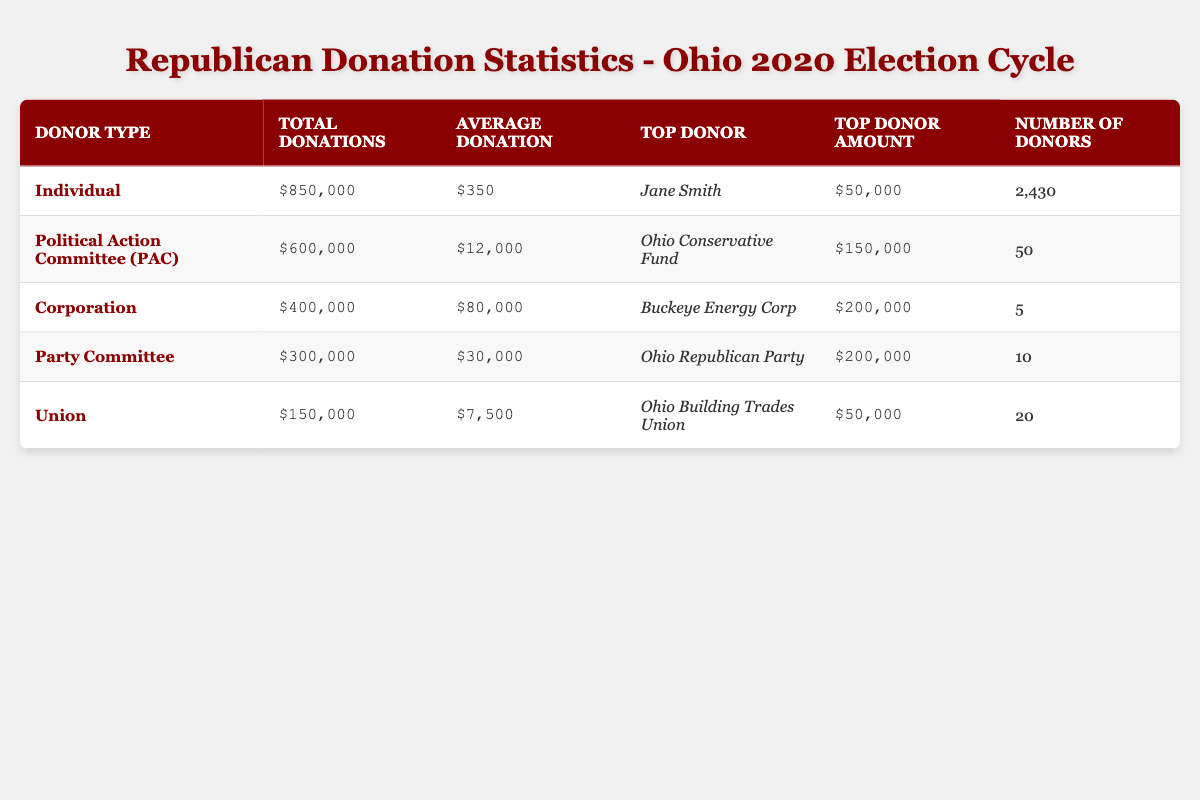What is the total amount donated by individual donors? The total donations from individuals are explicitly stated in the table as $850,000.
Answer: $850,000 Who is the top donor from corporations and how much did they donate? The table lists Buckeye Energy Corp as the top donor for corporations with a donation amount of $200,000.
Answer: Buckeye Energy Corp, $200,000 How many individual donors contributed during the 2020 election cycle? The table provides the number of individual donors as 2,430.
Answer: 2,430 What is the average donation amount from Political Action Committees (PACs)? The average donation from PACs is given in the table as $12,000.
Answer: $12,000 Which donor type had the highest total donations? By comparing total donations across donor types, individuals had the highest total donations of $850,000.
Answer: Individual What is the difference between total donations from corporations and from unions? Total donations from corporations are $400,000 and from unions are $150,000. The difference is $400,000 - $150,000 = $250,000.
Answer: $250,000 How many total donors contributed from all donor types combined? To find the total donors, sum the number of donors from all types: 2430 (individuals) + 50 (PACs) + 5 (corporations) + 10 (party committee) + 20 (union) = 2515.
Answer: 2,515 Is Ohio Republican Party the top donor for any donor type? Yes, Ohio Republican Party is listed as the top donor for the Party Committee with a donation amount of $200,000.
Answer: Yes What fraction of total donations comes from individual donors compared to the total donations from all donor types? Total donations from all donor types amount to $850,000 + $600,000 + $400,000 + $300,000 + $150,000 = $2,900,000. The fraction from individuals is $850,000 / $2,900,000 which simplifies to approximately 29.31%.
Answer: Approximately 29.31% Which donor type has the least total donations and how much was that? The union type has the least total donations listed as $150,000.
Answer: Union, $150,000 